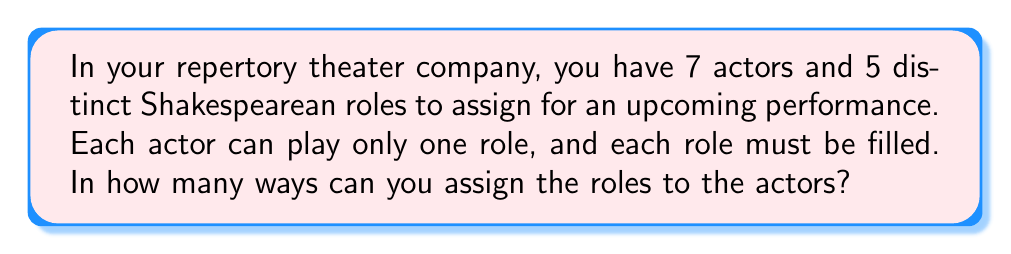Provide a solution to this math problem. Let's approach this step-by-step:

1) This is a permutation problem, specifically a partial permutation. We are selecting 5 actors out of 7 and arranging them in 5 positions (roles).

2) The formula for this type of problem is:

   $$P(n,r) = \frac{n!}{(n-r)!}$$

   Where $n$ is the total number of items (actors in this case) and $r$ is the number of items being arranged (roles in this case).

3) In our problem, $n = 7$ (total actors) and $r = 5$ (roles to be filled).

4) Let's substitute these values into our formula:

   $$P(7,5) = \frac{7!}{(7-5)!} = \frac{7!}{2!}$$

5) Expand this:
   $$\frac{7 * 6 * 5 * 4 * 3 * 2!}{2!}$$

6) The 2! cancels out in the numerator and denominator:
   $$7 * 6 * 5 * 4 * 3 = 2520$$

Therefore, there are 2520 ways to assign 5 roles to 7 actors.
Answer: 2520 